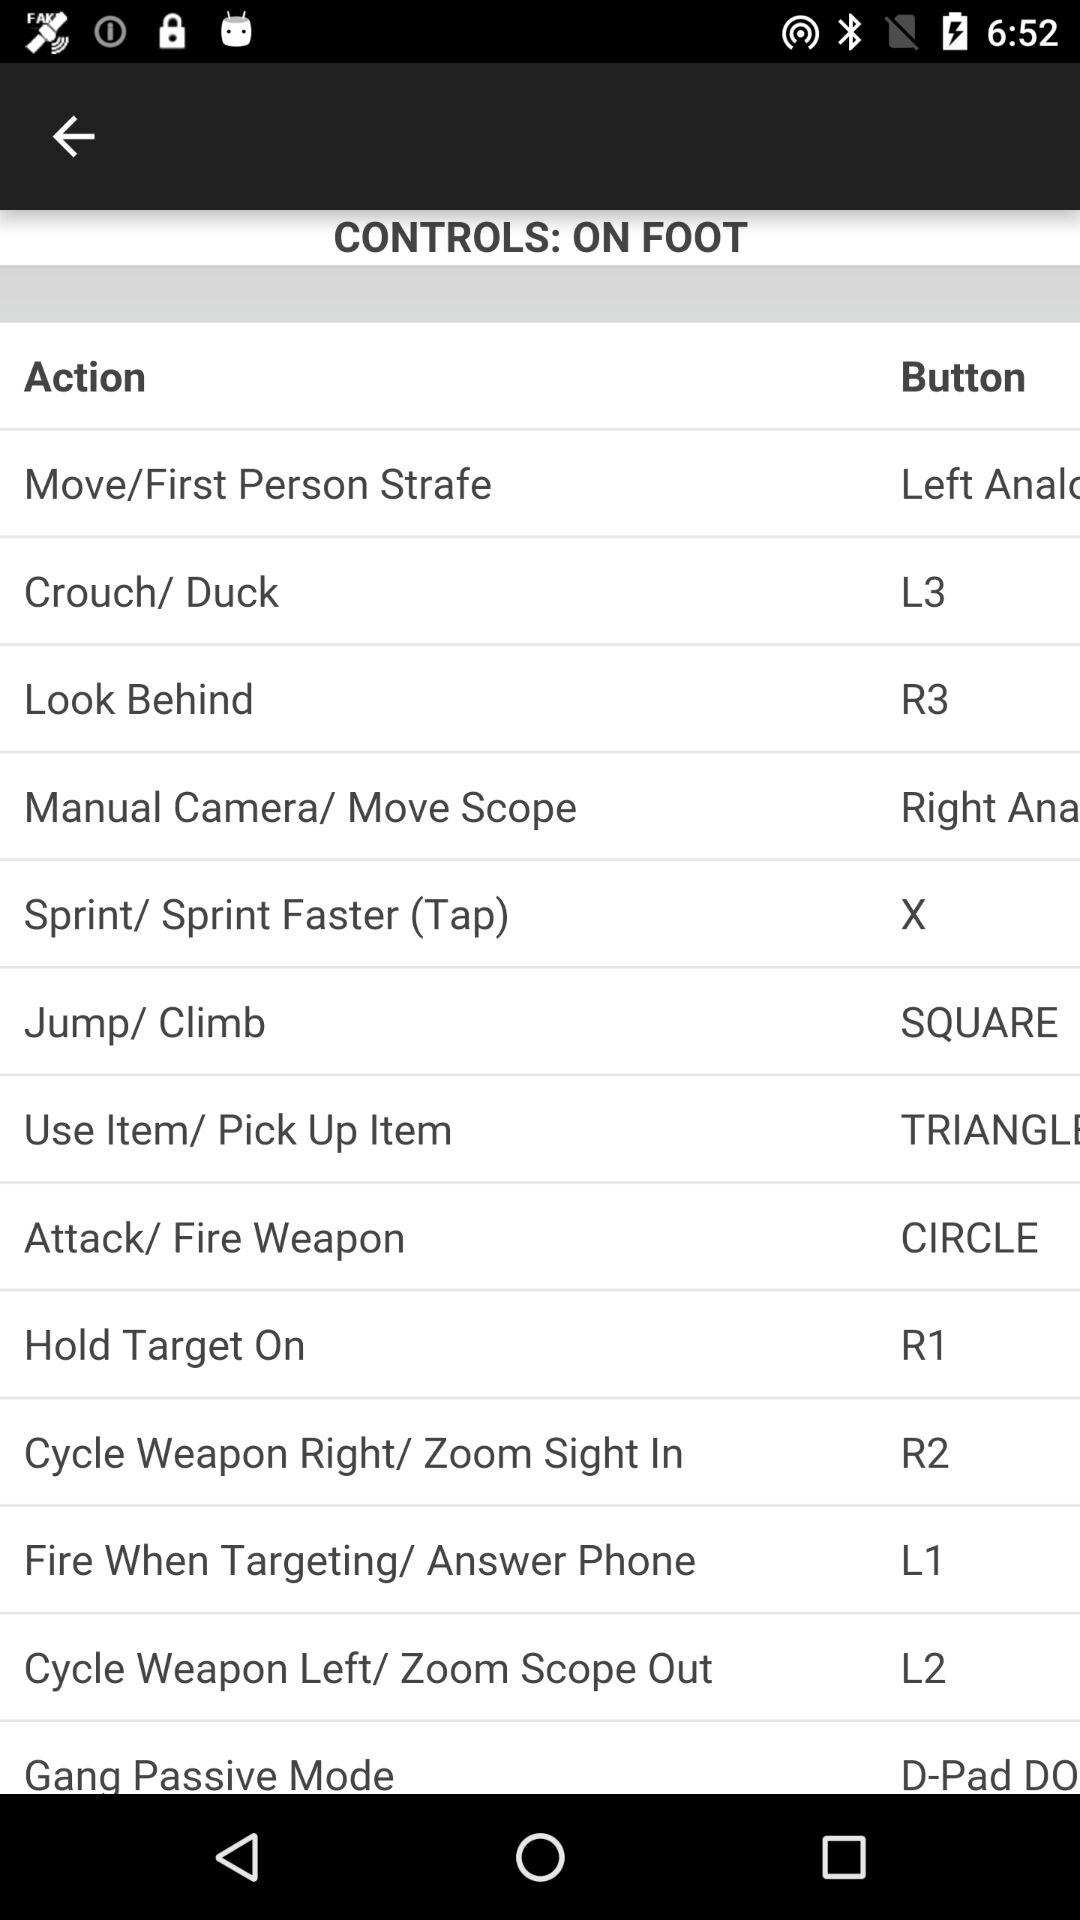What action does button "L2" perform? The "L2" button performs the action "Cycle Weapon Left/ Zoom Scope Out". 